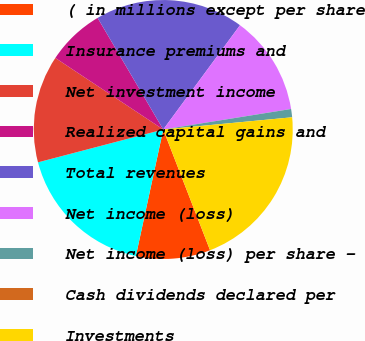<chart> <loc_0><loc_0><loc_500><loc_500><pie_chart><fcel>( in millions except per share<fcel>Insurance premiums and<fcel>Net investment income<fcel>Realized capital gains and<fcel>Total revenues<fcel>Net income (loss)<fcel>Net income (loss) per share -<fcel>Cash dividends declared per<fcel>Investments<nl><fcel>9.28%<fcel>17.53%<fcel>13.4%<fcel>7.22%<fcel>18.56%<fcel>12.37%<fcel>1.03%<fcel>0.0%<fcel>20.62%<nl></chart> 